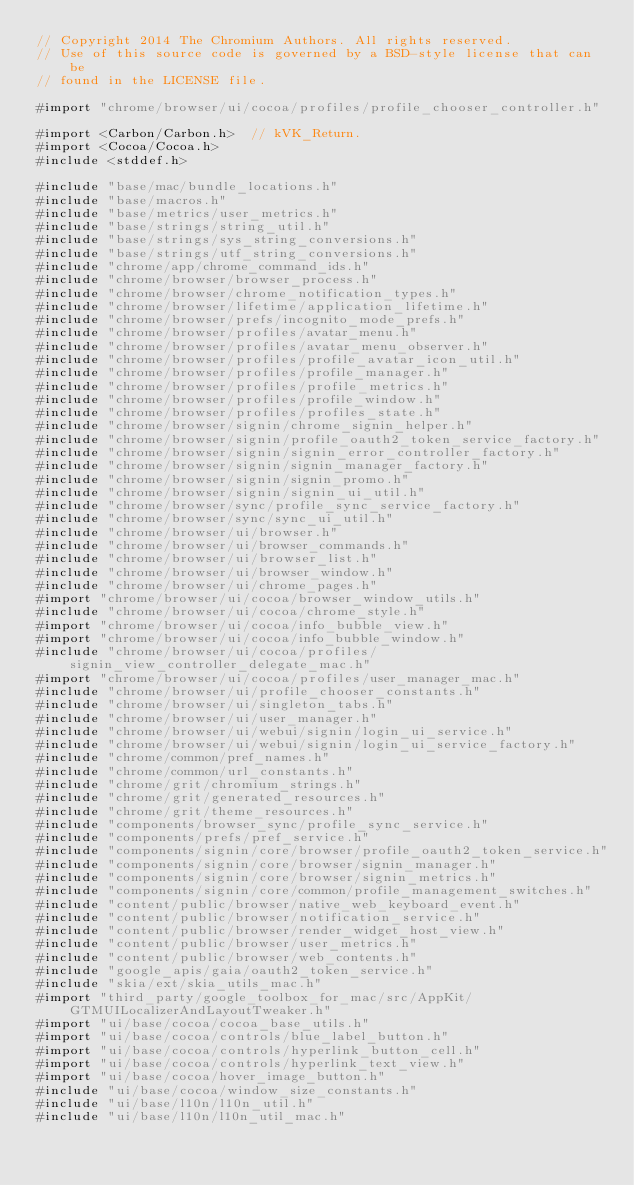Convert code to text. <code><loc_0><loc_0><loc_500><loc_500><_ObjectiveC_>// Copyright 2014 The Chromium Authors. All rights reserved.
// Use of this source code is governed by a BSD-style license that can be
// found in the LICENSE file.

#import "chrome/browser/ui/cocoa/profiles/profile_chooser_controller.h"

#import <Carbon/Carbon.h>  // kVK_Return.
#import <Cocoa/Cocoa.h>
#include <stddef.h>

#include "base/mac/bundle_locations.h"
#include "base/macros.h"
#include "base/metrics/user_metrics.h"
#include "base/strings/string_util.h"
#include "base/strings/sys_string_conversions.h"
#include "base/strings/utf_string_conversions.h"
#include "chrome/app/chrome_command_ids.h"
#include "chrome/browser/browser_process.h"
#include "chrome/browser/chrome_notification_types.h"
#include "chrome/browser/lifetime/application_lifetime.h"
#include "chrome/browser/prefs/incognito_mode_prefs.h"
#include "chrome/browser/profiles/avatar_menu.h"
#include "chrome/browser/profiles/avatar_menu_observer.h"
#include "chrome/browser/profiles/profile_avatar_icon_util.h"
#include "chrome/browser/profiles/profile_manager.h"
#include "chrome/browser/profiles/profile_metrics.h"
#include "chrome/browser/profiles/profile_window.h"
#include "chrome/browser/profiles/profiles_state.h"
#include "chrome/browser/signin/chrome_signin_helper.h"
#include "chrome/browser/signin/profile_oauth2_token_service_factory.h"
#include "chrome/browser/signin/signin_error_controller_factory.h"
#include "chrome/browser/signin/signin_manager_factory.h"
#include "chrome/browser/signin/signin_promo.h"
#include "chrome/browser/signin/signin_ui_util.h"
#include "chrome/browser/sync/profile_sync_service_factory.h"
#include "chrome/browser/sync/sync_ui_util.h"
#include "chrome/browser/ui/browser.h"
#include "chrome/browser/ui/browser_commands.h"
#include "chrome/browser/ui/browser_list.h"
#include "chrome/browser/ui/browser_window.h"
#include "chrome/browser/ui/chrome_pages.h"
#import "chrome/browser/ui/cocoa/browser_window_utils.h"
#include "chrome/browser/ui/cocoa/chrome_style.h"
#import "chrome/browser/ui/cocoa/info_bubble_view.h"
#import "chrome/browser/ui/cocoa/info_bubble_window.h"
#include "chrome/browser/ui/cocoa/profiles/signin_view_controller_delegate_mac.h"
#import "chrome/browser/ui/cocoa/profiles/user_manager_mac.h"
#include "chrome/browser/ui/profile_chooser_constants.h"
#include "chrome/browser/ui/singleton_tabs.h"
#include "chrome/browser/ui/user_manager.h"
#include "chrome/browser/ui/webui/signin/login_ui_service.h"
#include "chrome/browser/ui/webui/signin/login_ui_service_factory.h"
#include "chrome/common/pref_names.h"
#include "chrome/common/url_constants.h"
#include "chrome/grit/chromium_strings.h"
#include "chrome/grit/generated_resources.h"
#include "chrome/grit/theme_resources.h"
#include "components/browser_sync/profile_sync_service.h"
#include "components/prefs/pref_service.h"
#include "components/signin/core/browser/profile_oauth2_token_service.h"
#include "components/signin/core/browser/signin_manager.h"
#include "components/signin/core/browser/signin_metrics.h"
#include "components/signin/core/common/profile_management_switches.h"
#include "content/public/browser/native_web_keyboard_event.h"
#include "content/public/browser/notification_service.h"
#include "content/public/browser/render_widget_host_view.h"
#include "content/public/browser/user_metrics.h"
#include "content/public/browser/web_contents.h"
#include "google_apis/gaia/oauth2_token_service.h"
#include "skia/ext/skia_utils_mac.h"
#import "third_party/google_toolbox_for_mac/src/AppKit/GTMUILocalizerAndLayoutTweaker.h"
#import "ui/base/cocoa/cocoa_base_utils.h"
#import "ui/base/cocoa/controls/blue_label_button.h"
#import "ui/base/cocoa/controls/hyperlink_button_cell.h"
#import "ui/base/cocoa/controls/hyperlink_text_view.h"
#import "ui/base/cocoa/hover_image_button.h"
#include "ui/base/cocoa/window_size_constants.h"
#include "ui/base/l10n/l10n_util.h"
#include "ui/base/l10n/l10n_util_mac.h"</code> 